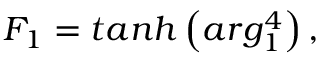Convert formula to latex. <formula><loc_0><loc_0><loc_500><loc_500>F _ { 1 } = t a n h \left ( \arg _ { 1 } ^ { 4 } \right ) ,</formula> 